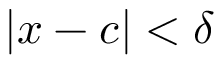<formula> <loc_0><loc_0><loc_500><loc_500>| x - c | < \delta</formula> 